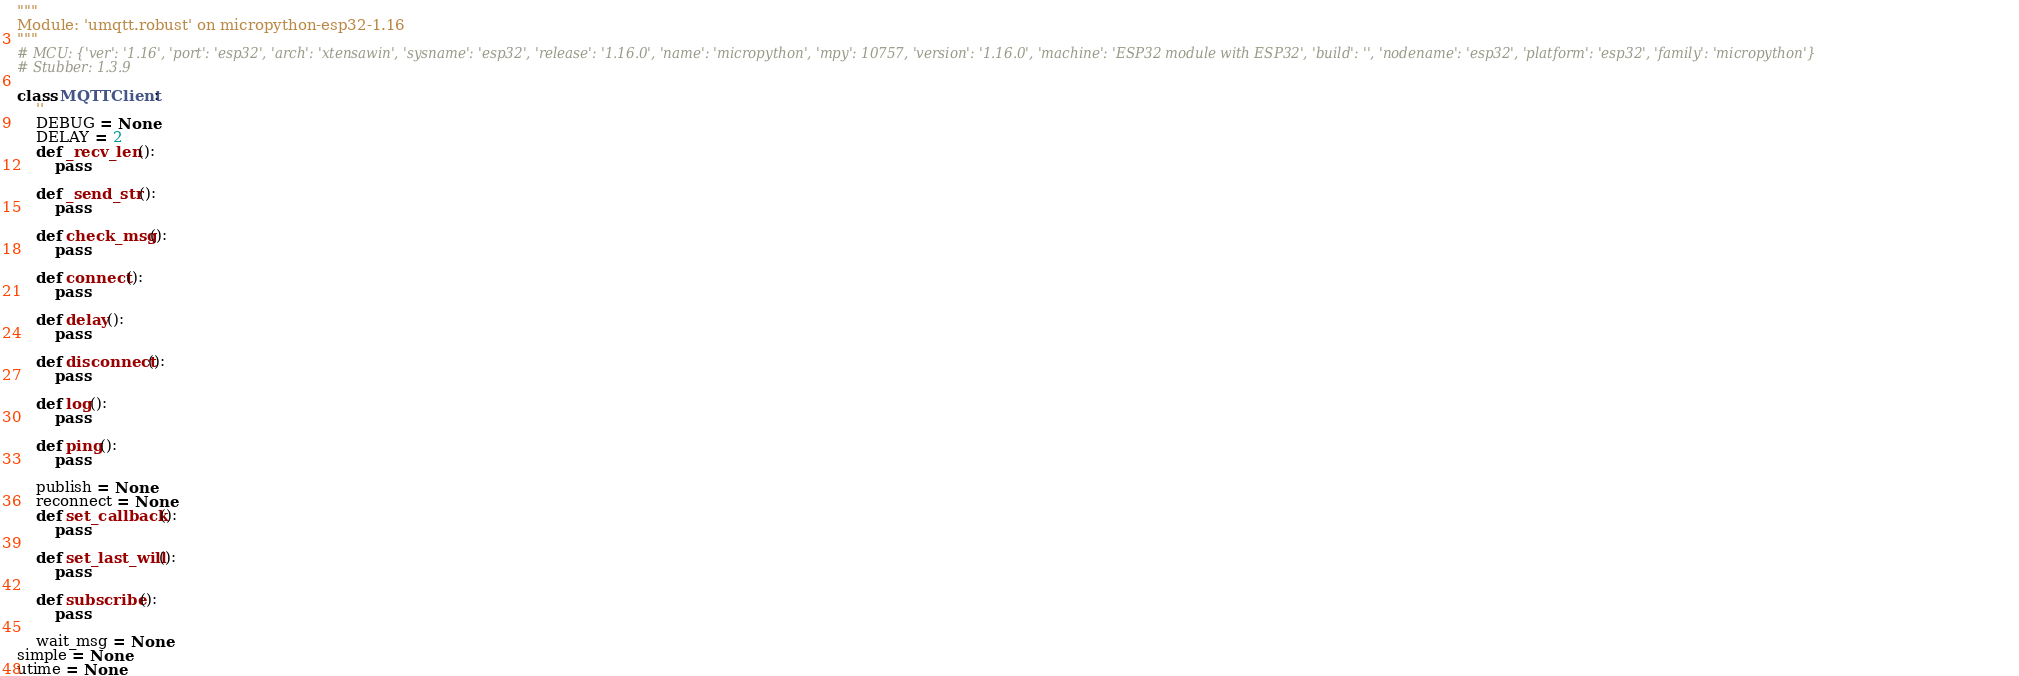Convert code to text. <code><loc_0><loc_0><loc_500><loc_500><_Python_>"""
Module: 'umqtt.robust' on micropython-esp32-1.16
"""
# MCU: {'ver': '1.16', 'port': 'esp32', 'arch': 'xtensawin', 'sysname': 'esp32', 'release': '1.16.0', 'name': 'micropython', 'mpy': 10757, 'version': '1.16.0', 'machine': 'ESP32 module with ESP32', 'build': '', 'nodename': 'esp32', 'platform': 'esp32', 'family': 'micropython'}
# Stubber: 1.3.9

class MQTTClient:
    ''
    DEBUG = None
    DELAY = 2
    def _recv_len():
        pass

    def _send_str():
        pass

    def check_msg():
        pass

    def connect():
        pass

    def delay():
        pass

    def disconnect():
        pass

    def log():
        pass

    def ping():
        pass

    publish = None
    reconnect = None
    def set_callback():
        pass

    def set_last_will():
        pass

    def subscribe():
        pass

    wait_msg = None
simple = None
utime = None
</code> 